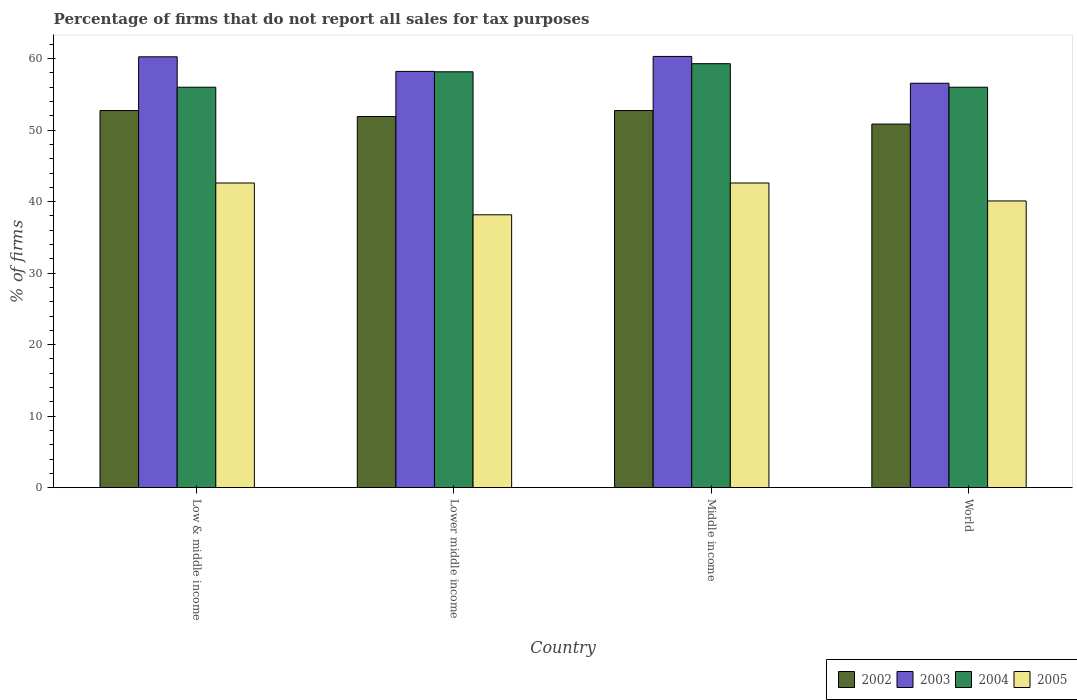Are the number of bars on each tick of the X-axis equal?
Offer a very short reply. Yes. How many bars are there on the 2nd tick from the left?
Offer a terse response. 4. What is the label of the 1st group of bars from the left?
Ensure brevity in your answer.  Low & middle income. In how many cases, is the number of bars for a given country not equal to the number of legend labels?
Offer a very short reply. 0. What is the percentage of firms that do not report all sales for tax purposes in 2004 in Low & middle income?
Your response must be concise. 56.01. Across all countries, what is the maximum percentage of firms that do not report all sales for tax purposes in 2004?
Offer a very short reply. 59.3. Across all countries, what is the minimum percentage of firms that do not report all sales for tax purposes in 2002?
Your answer should be very brief. 50.85. In which country was the percentage of firms that do not report all sales for tax purposes in 2005 minimum?
Your answer should be compact. Lower middle income. What is the total percentage of firms that do not report all sales for tax purposes in 2002 in the graph?
Provide a short and direct response. 208.25. What is the difference between the percentage of firms that do not report all sales for tax purposes in 2002 in Low & middle income and that in World?
Provide a short and direct response. 1.89. What is the difference between the percentage of firms that do not report all sales for tax purposes in 2004 in World and the percentage of firms that do not report all sales for tax purposes in 2005 in Low & middle income?
Offer a very short reply. 13.39. What is the average percentage of firms that do not report all sales for tax purposes in 2002 per country?
Provide a short and direct response. 52.06. What is the difference between the percentage of firms that do not report all sales for tax purposes of/in 2002 and percentage of firms that do not report all sales for tax purposes of/in 2003 in Lower middle income?
Ensure brevity in your answer.  -6.31. Is the percentage of firms that do not report all sales for tax purposes in 2003 in Lower middle income less than that in World?
Offer a very short reply. No. Is the difference between the percentage of firms that do not report all sales for tax purposes in 2002 in Middle income and World greater than the difference between the percentage of firms that do not report all sales for tax purposes in 2003 in Middle income and World?
Give a very brief answer. No. What is the difference between the highest and the second highest percentage of firms that do not report all sales for tax purposes in 2002?
Give a very brief answer. -0.84. What is the difference between the highest and the lowest percentage of firms that do not report all sales for tax purposes in 2003?
Offer a very short reply. 3.75. Is the sum of the percentage of firms that do not report all sales for tax purposes in 2005 in Lower middle income and Middle income greater than the maximum percentage of firms that do not report all sales for tax purposes in 2003 across all countries?
Provide a succinct answer. Yes. What does the 2nd bar from the left in Middle income represents?
Offer a terse response. 2003. What does the 4th bar from the right in World represents?
Give a very brief answer. 2002. Is it the case that in every country, the sum of the percentage of firms that do not report all sales for tax purposes in 2005 and percentage of firms that do not report all sales for tax purposes in 2002 is greater than the percentage of firms that do not report all sales for tax purposes in 2003?
Give a very brief answer. Yes. How many bars are there?
Offer a terse response. 16. Are all the bars in the graph horizontal?
Ensure brevity in your answer.  No. What is the difference between two consecutive major ticks on the Y-axis?
Your answer should be compact. 10. Does the graph contain any zero values?
Give a very brief answer. No. How are the legend labels stacked?
Give a very brief answer. Horizontal. What is the title of the graph?
Provide a short and direct response. Percentage of firms that do not report all sales for tax purposes. What is the label or title of the X-axis?
Ensure brevity in your answer.  Country. What is the label or title of the Y-axis?
Ensure brevity in your answer.  % of firms. What is the % of firms in 2002 in Low & middle income?
Keep it short and to the point. 52.75. What is the % of firms in 2003 in Low & middle income?
Offer a terse response. 60.26. What is the % of firms in 2004 in Low & middle income?
Give a very brief answer. 56.01. What is the % of firms of 2005 in Low & middle income?
Make the answer very short. 42.61. What is the % of firms in 2002 in Lower middle income?
Offer a very short reply. 51.91. What is the % of firms of 2003 in Lower middle income?
Keep it short and to the point. 58.22. What is the % of firms of 2004 in Lower middle income?
Your answer should be compact. 58.16. What is the % of firms of 2005 in Lower middle income?
Ensure brevity in your answer.  38.16. What is the % of firms of 2002 in Middle income?
Offer a terse response. 52.75. What is the % of firms of 2003 in Middle income?
Provide a short and direct response. 60.31. What is the % of firms of 2004 in Middle income?
Keep it short and to the point. 59.3. What is the % of firms of 2005 in Middle income?
Ensure brevity in your answer.  42.61. What is the % of firms in 2002 in World?
Your answer should be compact. 50.85. What is the % of firms of 2003 in World?
Provide a short and direct response. 56.56. What is the % of firms of 2004 in World?
Offer a very short reply. 56.01. What is the % of firms of 2005 in World?
Give a very brief answer. 40.1. Across all countries, what is the maximum % of firms of 2002?
Your answer should be compact. 52.75. Across all countries, what is the maximum % of firms of 2003?
Provide a succinct answer. 60.31. Across all countries, what is the maximum % of firms in 2004?
Offer a very short reply. 59.3. Across all countries, what is the maximum % of firms of 2005?
Give a very brief answer. 42.61. Across all countries, what is the minimum % of firms of 2002?
Provide a short and direct response. 50.85. Across all countries, what is the minimum % of firms of 2003?
Ensure brevity in your answer.  56.56. Across all countries, what is the minimum % of firms in 2004?
Offer a very short reply. 56.01. Across all countries, what is the minimum % of firms of 2005?
Make the answer very short. 38.16. What is the total % of firms of 2002 in the graph?
Provide a short and direct response. 208.25. What is the total % of firms of 2003 in the graph?
Your answer should be very brief. 235.35. What is the total % of firms of 2004 in the graph?
Your response must be concise. 229.47. What is the total % of firms of 2005 in the graph?
Make the answer very short. 163.48. What is the difference between the % of firms of 2002 in Low & middle income and that in Lower middle income?
Provide a succinct answer. 0.84. What is the difference between the % of firms in 2003 in Low & middle income and that in Lower middle income?
Your response must be concise. 2.04. What is the difference between the % of firms in 2004 in Low & middle income and that in Lower middle income?
Make the answer very short. -2.16. What is the difference between the % of firms of 2005 in Low & middle income and that in Lower middle income?
Provide a succinct answer. 4.45. What is the difference between the % of firms of 2002 in Low & middle income and that in Middle income?
Make the answer very short. 0. What is the difference between the % of firms in 2003 in Low & middle income and that in Middle income?
Offer a very short reply. -0.05. What is the difference between the % of firms in 2004 in Low & middle income and that in Middle income?
Offer a terse response. -3.29. What is the difference between the % of firms in 2005 in Low & middle income and that in Middle income?
Your answer should be very brief. 0. What is the difference between the % of firms in 2002 in Low & middle income and that in World?
Your answer should be compact. 1.89. What is the difference between the % of firms in 2003 in Low & middle income and that in World?
Your answer should be compact. 3.7. What is the difference between the % of firms in 2004 in Low & middle income and that in World?
Provide a short and direct response. 0. What is the difference between the % of firms of 2005 in Low & middle income and that in World?
Your answer should be very brief. 2.51. What is the difference between the % of firms of 2002 in Lower middle income and that in Middle income?
Provide a succinct answer. -0.84. What is the difference between the % of firms in 2003 in Lower middle income and that in Middle income?
Keep it short and to the point. -2.09. What is the difference between the % of firms of 2004 in Lower middle income and that in Middle income?
Your answer should be very brief. -1.13. What is the difference between the % of firms in 2005 in Lower middle income and that in Middle income?
Offer a very short reply. -4.45. What is the difference between the % of firms in 2002 in Lower middle income and that in World?
Keep it short and to the point. 1.06. What is the difference between the % of firms in 2003 in Lower middle income and that in World?
Offer a very short reply. 1.66. What is the difference between the % of firms of 2004 in Lower middle income and that in World?
Offer a very short reply. 2.16. What is the difference between the % of firms of 2005 in Lower middle income and that in World?
Keep it short and to the point. -1.94. What is the difference between the % of firms in 2002 in Middle income and that in World?
Your response must be concise. 1.89. What is the difference between the % of firms of 2003 in Middle income and that in World?
Provide a succinct answer. 3.75. What is the difference between the % of firms of 2004 in Middle income and that in World?
Keep it short and to the point. 3.29. What is the difference between the % of firms of 2005 in Middle income and that in World?
Give a very brief answer. 2.51. What is the difference between the % of firms of 2002 in Low & middle income and the % of firms of 2003 in Lower middle income?
Offer a terse response. -5.47. What is the difference between the % of firms of 2002 in Low & middle income and the % of firms of 2004 in Lower middle income?
Your answer should be compact. -5.42. What is the difference between the % of firms of 2002 in Low & middle income and the % of firms of 2005 in Lower middle income?
Offer a very short reply. 14.58. What is the difference between the % of firms of 2003 in Low & middle income and the % of firms of 2004 in Lower middle income?
Make the answer very short. 2.1. What is the difference between the % of firms of 2003 in Low & middle income and the % of firms of 2005 in Lower middle income?
Your answer should be very brief. 22.1. What is the difference between the % of firms in 2004 in Low & middle income and the % of firms in 2005 in Lower middle income?
Ensure brevity in your answer.  17.84. What is the difference between the % of firms in 2002 in Low & middle income and the % of firms in 2003 in Middle income?
Ensure brevity in your answer.  -7.57. What is the difference between the % of firms in 2002 in Low & middle income and the % of firms in 2004 in Middle income?
Your response must be concise. -6.55. What is the difference between the % of firms in 2002 in Low & middle income and the % of firms in 2005 in Middle income?
Keep it short and to the point. 10.13. What is the difference between the % of firms of 2003 in Low & middle income and the % of firms of 2004 in Middle income?
Make the answer very short. 0.96. What is the difference between the % of firms in 2003 in Low & middle income and the % of firms in 2005 in Middle income?
Offer a very short reply. 17.65. What is the difference between the % of firms in 2004 in Low & middle income and the % of firms in 2005 in Middle income?
Offer a very short reply. 13.39. What is the difference between the % of firms in 2002 in Low & middle income and the % of firms in 2003 in World?
Make the answer very short. -3.81. What is the difference between the % of firms in 2002 in Low & middle income and the % of firms in 2004 in World?
Offer a very short reply. -3.26. What is the difference between the % of firms in 2002 in Low & middle income and the % of firms in 2005 in World?
Your answer should be compact. 12.65. What is the difference between the % of firms in 2003 in Low & middle income and the % of firms in 2004 in World?
Ensure brevity in your answer.  4.25. What is the difference between the % of firms of 2003 in Low & middle income and the % of firms of 2005 in World?
Your answer should be very brief. 20.16. What is the difference between the % of firms in 2004 in Low & middle income and the % of firms in 2005 in World?
Provide a short and direct response. 15.91. What is the difference between the % of firms in 2002 in Lower middle income and the % of firms in 2003 in Middle income?
Keep it short and to the point. -8.4. What is the difference between the % of firms in 2002 in Lower middle income and the % of firms in 2004 in Middle income?
Offer a terse response. -7.39. What is the difference between the % of firms of 2002 in Lower middle income and the % of firms of 2005 in Middle income?
Your answer should be very brief. 9.3. What is the difference between the % of firms in 2003 in Lower middle income and the % of firms in 2004 in Middle income?
Keep it short and to the point. -1.08. What is the difference between the % of firms in 2003 in Lower middle income and the % of firms in 2005 in Middle income?
Ensure brevity in your answer.  15.61. What is the difference between the % of firms in 2004 in Lower middle income and the % of firms in 2005 in Middle income?
Your response must be concise. 15.55. What is the difference between the % of firms of 2002 in Lower middle income and the % of firms of 2003 in World?
Offer a terse response. -4.65. What is the difference between the % of firms in 2002 in Lower middle income and the % of firms in 2004 in World?
Provide a succinct answer. -4.1. What is the difference between the % of firms of 2002 in Lower middle income and the % of firms of 2005 in World?
Your answer should be compact. 11.81. What is the difference between the % of firms of 2003 in Lower middle income and the % of firms of 2004 in World?
Keep it short and to the point. 2.21. What is the difference between the % of firms of 2003 in Lower middle income and the % of firms of 2005 in World?
Ensure brevity in your answer.  18.12. What is the difference between the % of firms of 2004 in Lower middle income and the % of firms of 2005 in World?
Provide a succinct answer. 18.07. What is the difference between the % of firms in 2002 in Middle income and the % of firms in 2003 in World?
Your response must be concise. -3.81. What is the difference between the % of firms of 2002 in Middle income and the % of firms of 2004 in World?
Offer a very short reply. -3.26. What is the difference between the % of firms in 2002 in Middle income and the % of firms in 2005 in World?
Offer a very short reply. 12.65. What is the difference between the % of firms of 2003 in Middle income and the % of firms of 2004 in World?
Your response must be concise. 4.31. What is the difference between the % of firms in 2003 in Middle income and the % of firms in 2005 in World?
Provide a succinct answer. 20.21. What is the difference between the % of firms of 2004 in Middle income and the % of firms of 2005 in World?
Provide a succinct answer. 19.2. What is the average % of firms in 2002 per country?
Offer a terse response. 52.06. What is the average % of firms in 2003 per country?
Offer a very short reply. 58.84. What is the average % of firms in 2004 per country?
Give a very brief answer. 57.37. What is the average % of firms of 2005 per country?
Your answer should be very brief. 40.87. What is the difference between the % of firms in 2002 and % of firms in 2003 in Low & middle income?
Your answer should be compact. -7.51. What is the difference between the % of firms in 2002 and % of firms in 2004 in Low & middle income?
Provide a short and direct response. -3.26. What is the difference between the % of firms of 2002 and % of firms of 2005 in Low & middle income?
Offer a very short reply. 10.13. What is the difference between the % of firms of 2003 and % of firms of 2004 in Low & middle income?
Keep it short and to the point. 4.25. What is the difference between the % of firms in 2003 and % of firms in 2005 in Low & middle income?
Offer a terse response. 17.65. What is the difference between the % of firms in 2004 and % of firms in 2005 in Low & middle income?
Your answer should be compact. 13.39. What is the difference between the % of firms of 2002 and % of firms of 2003 in Lower middle income?
Your answer should be compact. -6.31. What is the difference between the % of firms in 2002 and % of firms in 2004 in Lower middle income?
Your response must be concise. -6.26. What is the difference between the % of firms in 2002 and % of firms in 2005 in Lower middle income?
Give a very brief answer. 13.75. What is the difference between the % of firms in 2003 and % of firms in 2004 in Lower middle income?
Provide a short and direct response. 0.05. What is the difference between the % of firms of 2003 and % of firms of 2005 in Lower middle income?
Ensure brevity in your answer.  20.06. What is the difference between the % of firms in 2004 and % of firms in 2005 in Lower middle income?
Provide a succinct answer. 20. What is the difference between the % of firms in 2002 and % of firms in 2003 in Middle income?
Keep it short and to the point. -7.57. What is the difference between the % of firms of 2002 and % of firms of 2004 in Middle income?
Ensure brevity in your answer.  -6.55. What is the difference between the % of firms of 2002 and % of firms of 2005 in Middle income?
Provide a short and direct response. 10.13. What is the difference between the % of firms of 2003 and % of firms of 2004 in Middle income?
Your answer should be compact. 1.02. What is the difference between the % of firms in 2003 and % of firms in 2005 in Middle income?
Ensure brevity in your answer.  17.7. What is the difference between the % of firms in 2004 and % of firms in 2005 in Middle income?
Keep it short and to the point. 16.69. What is the difference between the % of firms of 2002 and % of firms of 2003 in World?
Your answer should be compact. -5.71. What is the difference between the % of firms of 2002 and % of firms of 2004 in World?
Provide a succinct answer. -5.15. What is the difference between the % of firms in 2002 and % of firms in 2005 in World?
Offer a very short reply. 10.75. What is the difference between the % of firms in 2003 and % of firms in 2004 in World?
Provide a succinct answer. 0.56. What is the difference between the % of firms of 2003 and % of firms of 2005 in World?
Your answer should be very brief. 16.46. What is the difference between the % of firms in 2004 and % of firms in 2005 in World?
Make the answer very short. 15.91. What is the ratio of the % of firms in 2002 in Low & middle income to that in Lower middle income?
Ensure brevity in your answer.  1.02. What is the ratio of the % of firms of 2003 in Low & middle income to that in Lower middle income?
Ensure brevity in your answer.  1.04. What is the ratio of the % of firms of 2004 in Low & middle income to that in Lower middle income?
Your response must be concise. 0.96. What is the ratio of the % of firms of 2005 in Low & middle income to that in Lower middle income?
Ensure brevity in your answer.  1.12. What is the ratio of the % of firms in 2004 in Low & middle income to that in Middle income?
Give a very brief answer. 0.94. What is the ratio of the % of firms in 2002 in Low & middle income to that in World?
Offer a very short reply. 1.04. What is the ratio of the % of firms in 2003 in Low & middle income to that in World?
Provide a short and direct response. 1.07. What is the ratio of the % of firms in 2004 in Low & middle income to that in World?
Offer a terse response. 1. What is the ratio of the % of firms in 2005 in Low & middle income to that in World?
Give a very brief answer. 1.06. What is the ratio of the % of firms in 2002 in Lower middle income to that in Middle income?
Give a very brief answer. 0.98. What is the ratio of the % of firms in 2003 in Lower middle income to that in Middle income?
Provide a succinct answer. 0.97. What is the ratio of the % of firms of 2004 in Lower middle income to that in Middle income?
Make the answer very short. 0.98. What is the ratio of the % of firms in 2005 in Lower middle income to that in Middle income?
Make the answer very short. 0.9. What is the ratio of the % of firms in 2002 in Lower middle income to that in World?
Offer a terse response. 1.02. What is the ratio of the % of firms of 2003 in Lower middle income to that in World?
Your answer should be compact. 1.03. What is the ratio of the % of firms in 2004 in Lower middle income to that in World?
Offer a terse response. 1.04. What is the ratio of the % of firms in 2005 in Lower middle income to that in World?
Offer a very short reply. 0.95. What is the ratio of the % of firms in 2002 in Middle income to that in World?
Keep it short and to the point. 1.04. What is the ratio of the % of firms in 2003 in Middle income to that in World?
Give a very brief answer. 1.07. What is the ratio of the % of firms in 2004 in Middle income to that in World?
Your answer should be compact. 1.06. What is the ratio of the % of firms of 2005 in Middle income to that in World?
Provide a short and direct response. 1.06. What is the difference between the highest and the second highest % of firms in 2002?
Provide a short and direct response. 0. What is the difference between the highest and the second highest % of firms in 2003?
Offer a terse response. 0.05. What is the difference between the highest and the second highest % of firms in 2004?
Your response must be concise. 1.13. What is the difference between the highest and the second highest % of firms in 2005?
Your answer should be very brief. 0. What is the difference between the highest and the lowest % of firms in 2002?
Your answer should be very brief. 1.89. What is the difference between the highest and the lowest % of firms of 2003?
Your answer should be compact. 3.75. What is the difference between the highest and the lowest % of firms of 2004?
Offer a terse response. 3.29. What is the difference between the highest and the lowest % of firms of 2005?
Ensure brevity in your answer.  4.45. 